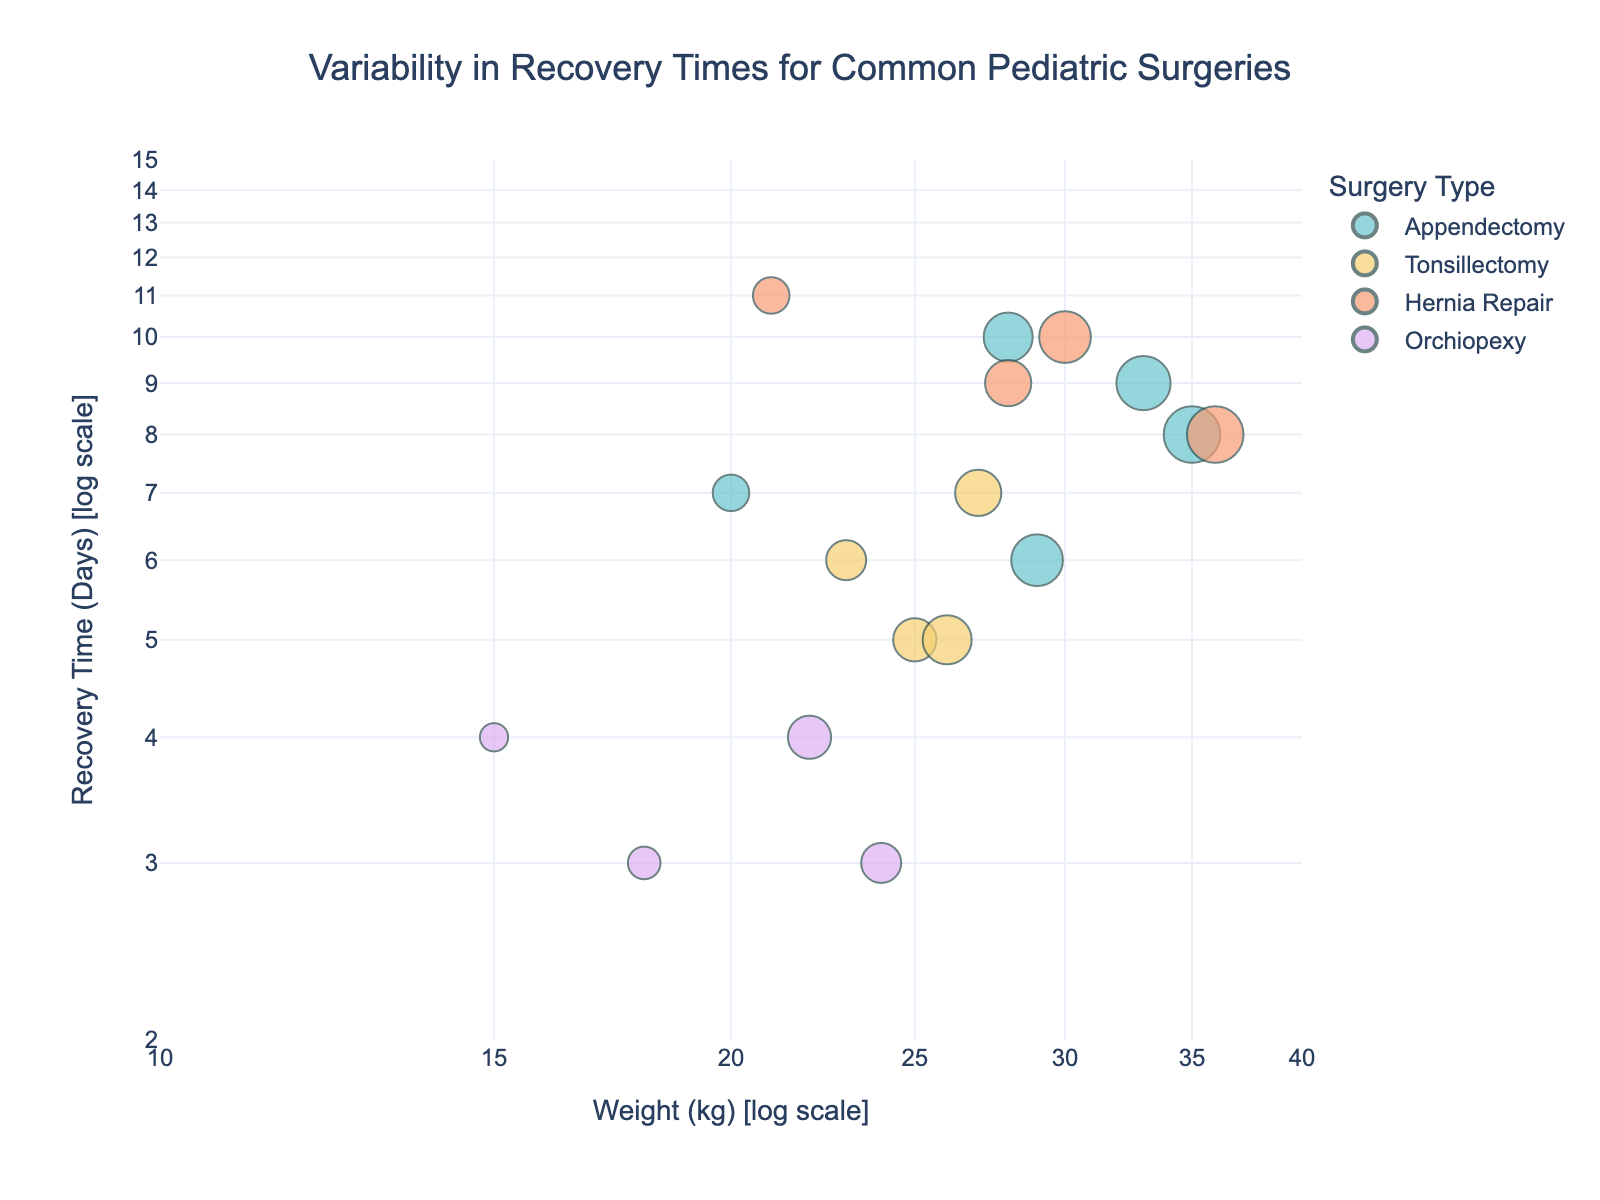What's the title of the figure? The title of the figure is displayed at the top and is "Variability in Recovery Times for Common Pediatric Surgeries".
Answer: Variability in Recovery Times for Common Pediatric Surgeries What are the x-axis and y-axis labels? The x-axis label is "Weight (kg) [log scale]", and the y-axis label is "Recovery Time (Days) [log scale]".
Answer: Weight (kg) [log scale], Recovery Time (Days) [log scale] How many different surgery types are represented in the plot? The scatter plot uses different colors to represent surgery types. There are four distinct colors, representing four different surgery types.
Answer: Four Which surgery type has the widest variability in recovery times? By observing the range of recovery times for each surgery type on the y-axis, "Hernia Repair" shows recovery times ranging from 8 to 11 days, indicating the widest variability.
Answer: Hernia Repair What's the average recovery time for Appendectomy across all ages? Identify all data points for Appendectomy and sum their recovery times (7 + 8 + 9 + 6 + 10 = 40 days). Divide by the number of data points (5).
Answer: 8 days Which age group has the shortest average recovery time and what is that average? Calculate the average recovery time for each distinct age group. The group with the lowest average will have the shortest recovery time. For example, 3-year-olds have only one data point (4 days). After calculations:
   - 3 years: (4 / 1) = 4 days
   - 4 years: (3 / 1) = 3 days
   - 5 years: (7 + 11 / 2) = 9 days
   - 6 years: (6 + 3 / 2) = 4.5 days
   - 7 years: (5 + 4 / 2) = 4.5 days
   - 8 years: (9 + 7 / 2) = 8 days
   - 9 years: (5 + 10 / 2) = 7.5 days
   - 10 years: (10 + 6 / 2) = 8 days
   - 11 years: (9 / 1) = 9 days
   - 12 years: (8 + 8 / 2) = 8 days
So, 4-year-olds with 3 days on average.
Answer: 4 years, 3 days Which surgery has the highest recovery time for patients who weigh 20 kg or less? Look for the data points with weights of 20 kg or less. For these points, check which surgery has the highest recovery time. An Appendectomy for a 5-year-old weighing 20 kg has a recovery time of 7 days.
Answer: Appendectomy Are there any outliers in the recovery times for any surgeries? The outliers can be identified when a point significantly deviates from other points of the same surgery type. For Hernia Repair, one child (5 years old, 21 kg) has a recovery time of 11 days, which appears higher compared to others.
Answer: 5 years old, 21 kg, Recovery time 11 days Which surgery type generally has the quickest recovery times? By analyzing the lower end of the y-axis, "Orchiopexy" typically has data points at 3, 3, and 4 days recovery times, showing quickest recoveries.
Answer: Orchiopexy 